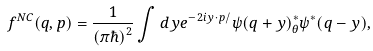<formula> <loc_0><loc_0><loc_500><loc_500>f ^ { N C } ( q , p ) = \frac { 1 } { ( \pi \hbar { ) } ^ { 2 } } \int d y e ^ { - 2 i y \cdot p / } \psi ( q + y ) ^ { * } _ { \theta } \psi ^ { * } ( q - y ) ,</formula> 